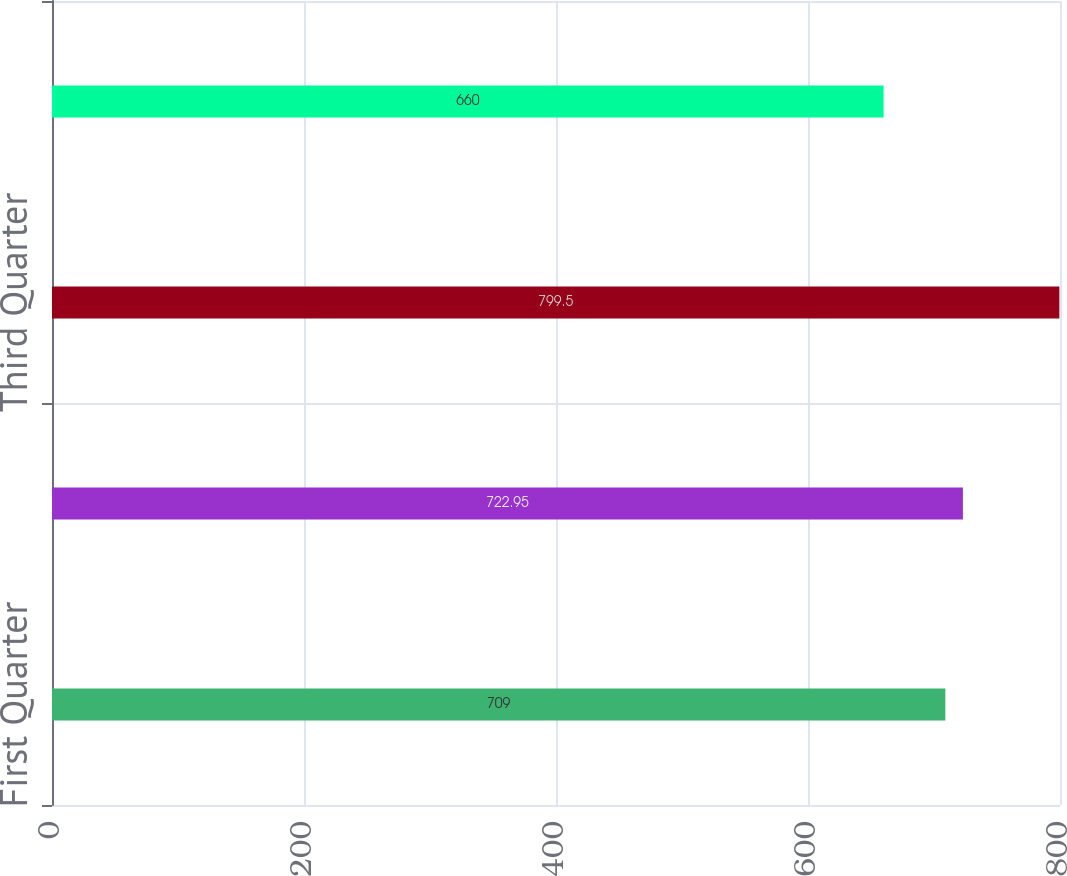Convert chart. <chart><loc_0><loc_0><loc_500><loc_500><bar_chart><fcel>First Quarter<fcel>Second Quarter<fcel>Third Quarter<fcel>Fourth Quarter<nl><fcel>709<fcel>722.95<fcel>799.5<fcel>660<nl></chart> 